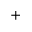Convert formula to latex. <formula><loc_0><loc_0><loc_500><loc_500>^ { + }</formula> 